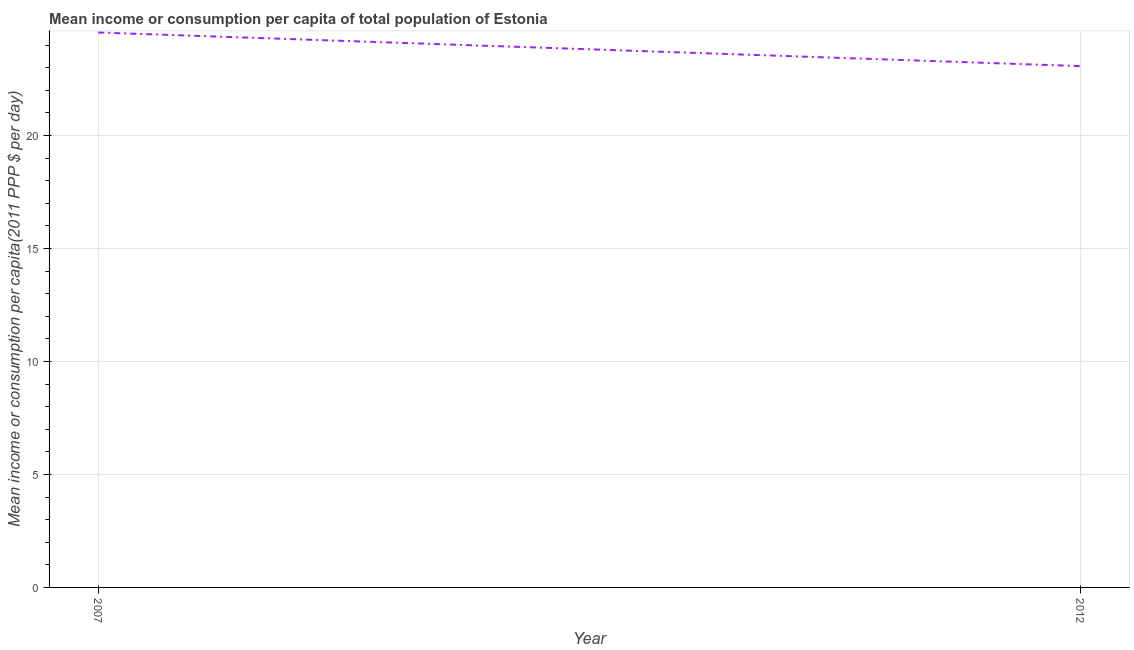What is the mean income or consumption in 2012?
Offer a terse response. 23.07. Across all years, what is the maximum mean income or consumption?
Ensure brevity in your answer.  24.56. Across all years, what is the minimum mean income or consumption?
Offer a terse response. 23.07. What is the sum of the mean income or consumption?
Provide a succinct answer. 47.64. What is the difference between the mean income or consumption in 2007 and 2012?
Make the answer very short. 1.49. What is the average mean income or consumption per year?
Offer a terse response. 23.82. What is the median mean income or consumption?
Your response must be concise. 23.82. In how many years, is the mean income or consumption greater than 12 $?
Give a very brief answer. 2. What is the ratio of the mean income or consumption in 2007 to that in 2012?
Provide a short and direct response. 1.06. Is the mean income or consumption in 2007 less than that in 2012?
Offer a terse response. No. In how many years, is the mean income or consumption greater than the average mean income or consumption taken over all years?
Keep it short and to the point. 1. What is the difference between two consecutive major ticks on the Y-axis?
Keep it short and to the point. 5. Does the graph contain any zero values?
Your response must be concise. No. What is the title of the graph?
Make the answer very short. Mean income or consumption per capita of total population of Estonia. What is the label or title of the Y-axis?
Your response must be concise. Mean income or consumption per capita(2011 PPP $ per day). What is the Mean income or consumption per capita(2011 PPP $ per day) in 2007?
Provide a short and direct response. 24.56. What is the Mean income or consumption per capita(2011 PPP $ per day) of 2012?
Your answer should be very brief. 23.07. What is the difference between the Mean income or consumption per capita(2011 PPP $ per day) in 2007 and 2012?
Your answer should be compact. 1.49. What is the ratio of the Mean income or consumption per capita(2011 PPP $ per day) in 2007 to that in 2012?
Make the answer very short. 1.06. 